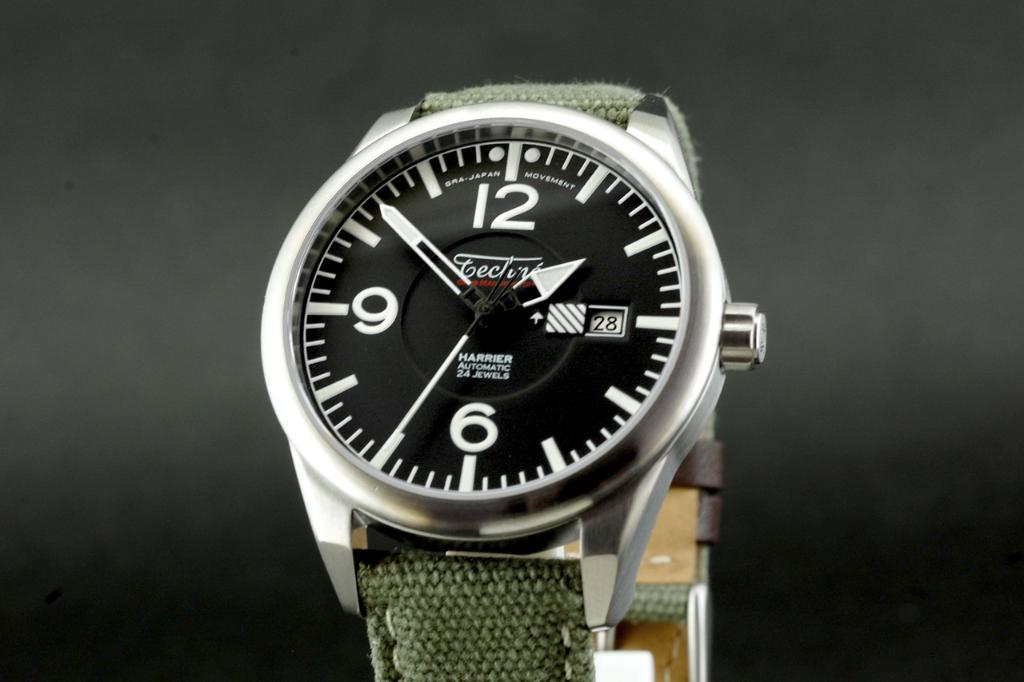<image>
Give a short and clear explanation of the subsequent image. A Harrier watch is displayed over a dark background. 